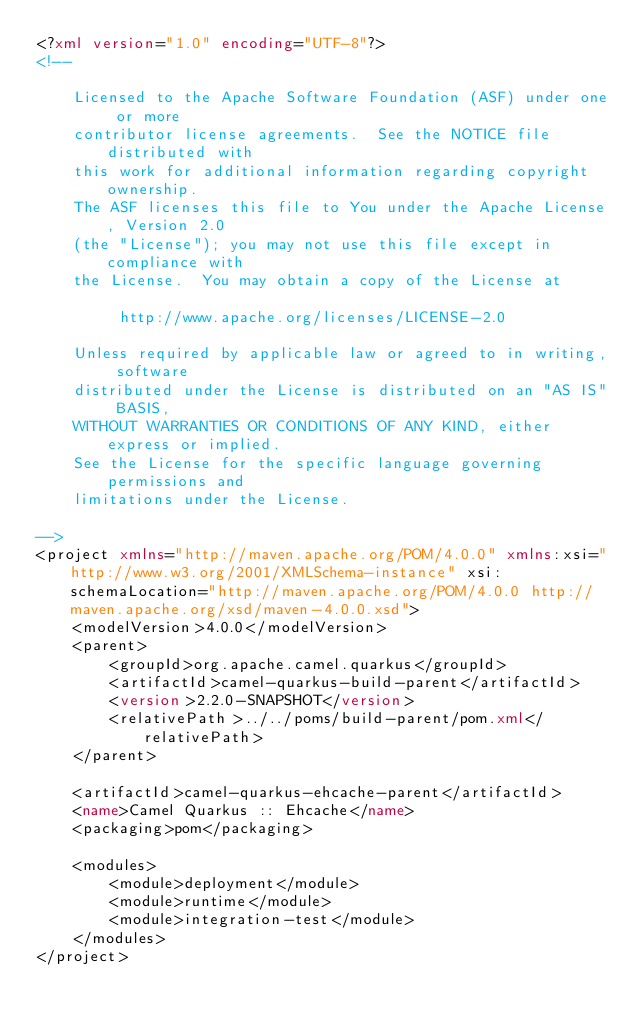<code> <loc_0><loc_0><loc_500><loc_500><_XML_><?xml version="1.0" encoding="UTF-8"?>
<!--

    Licensed to the Apache Software Foundation (ASF) under one or more
    contributor license agreements.  See the NOTICE file distributed with
    this work for additional information regarding copyright ownership.
    The ASF licenses this file to You under the Apache License, Version 2.0
    (the "License"); you may not use this file except in compliance with
    the License.  You may obtain a copy of the License at

         http://www.apache.org/licenses/LICENSE-2.0

    Unless required by applicable law or agreed to in writing, software
    distributed under the License is distributed on an "AS IS" BASIS,
    WITHOUT WARRANTIES OR CONDITIONS OF ANY KIND, either express or implied.
    See the License for the specific language governing permissions and
    limitations under the License.

-->
<project xmlns="http://maven.apache.org/POM/4.0.0" xmlns:xsi="http://www.w3.org/2001/XMLSchema-instance" xsi:schemaLocation="http://maven.apache.org/POM/4.0.0 http://maven.apache.org/xsd/maven-4.0.0.xsd">
    <modelVersion>4.0.0</modelVersion>
    <parent>
        <groupId>org.apache.camel.quarkus</groupId>
        <artifactId>camel-quarkus-build-parent</artifactId>
        <version>2.2.0-SNAPSHOT</version>
        <relativePath>../../poms/build-parent/pom.xml</relativePath>
    </parent>

    <artifactId>camel-quarkus-ehcache-parent</artifactId>
    <name>Camel Quarkus :: Ehcache</name>
    <packaging>pom</packaging>

    <modules>
        <module>deployment</module>
        <module>runtime</module>
        <module>integration-test</module>
    </modules>
</project>
</code> 